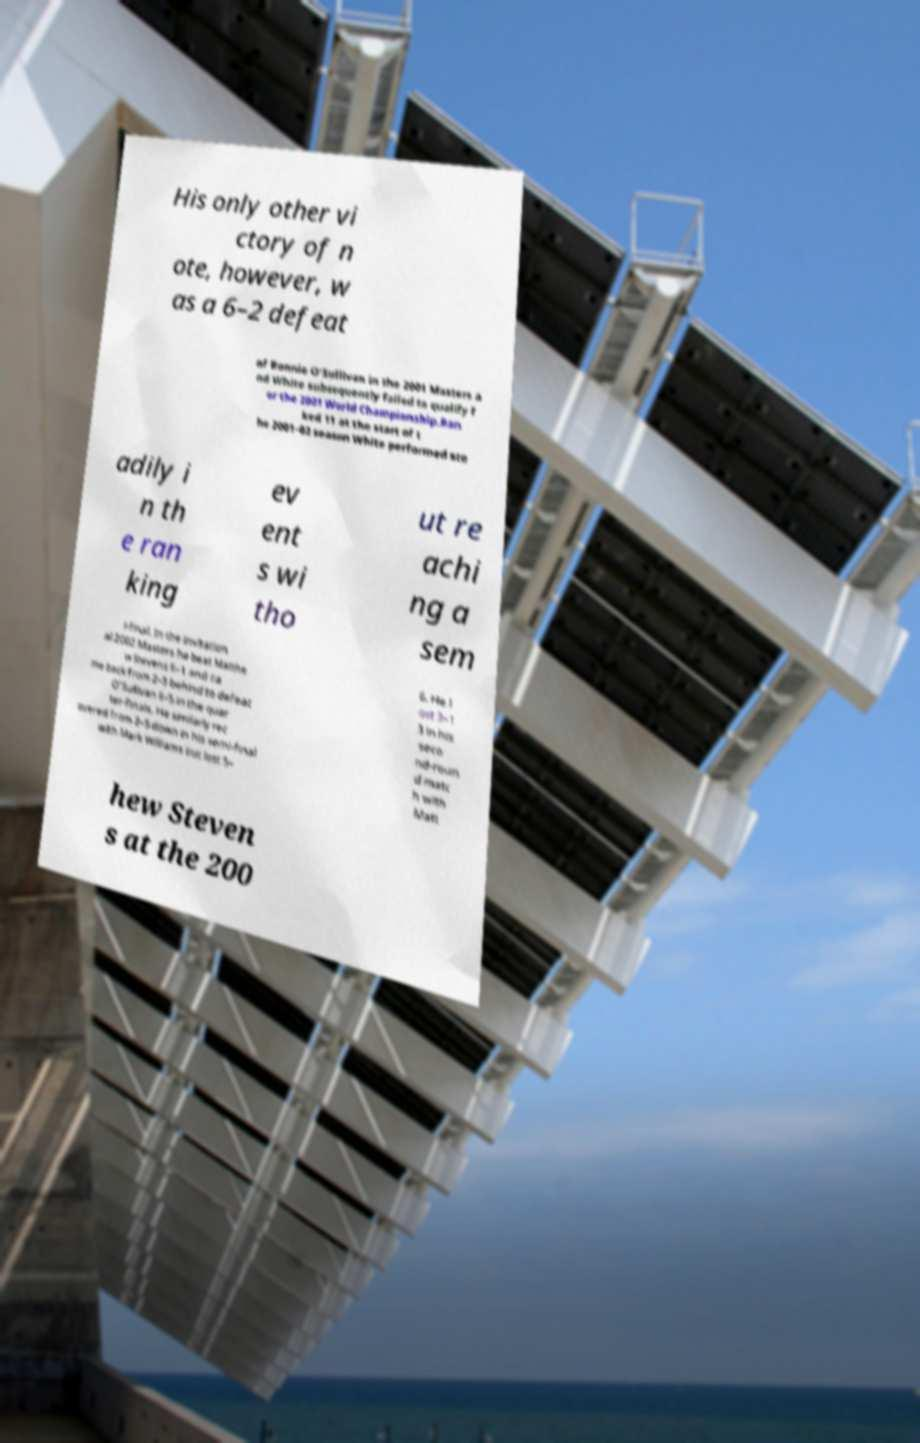Can you read and provide the text displayed in the image?This photo seems to have some interesting text. Can you extract and type it out for me? His only other vi ctory of n ote, however, w as a 6–2 defeat of Ronnie O'Sullivan in the 2001 Masters a nd White subsequently failed to qualify f or the 2001 World Championship.Ran ked 11 at the start of t he 2001–02 season White performed ste adily i n th e ran king ev ent s wi tho ut re achi ng a sem i-final. In the invitation al 2002 Masters he beat Matthe w Stevens 6–1 and ca me back from 2–5 behind to defeat O'Sullivan 6–5 in the quar ter-finals. He similarly rec overed from 2–5 down in his semi-final with Mark Williams but lost 5– 6. He l ost 3–1 3 in his seco nd-roun d matc h with Matt hew Steven s at the 200 